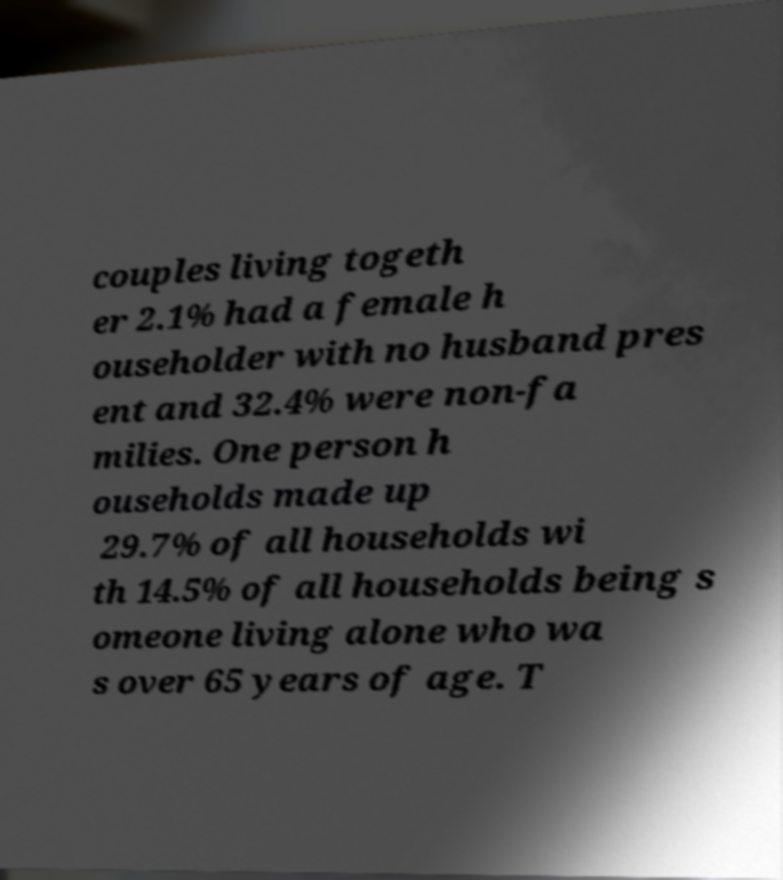Could you assist in decoding the text presented in this image and type it out clearly? couples living togeth er 2.1% had a female h ouseholder with no husband pres ent and 32.4% were non-fa milies. One person h ouseholds made up 29.7% of all households wi th 14.5% of all households being s omeone living alone who wa s over 65 years of age. T 